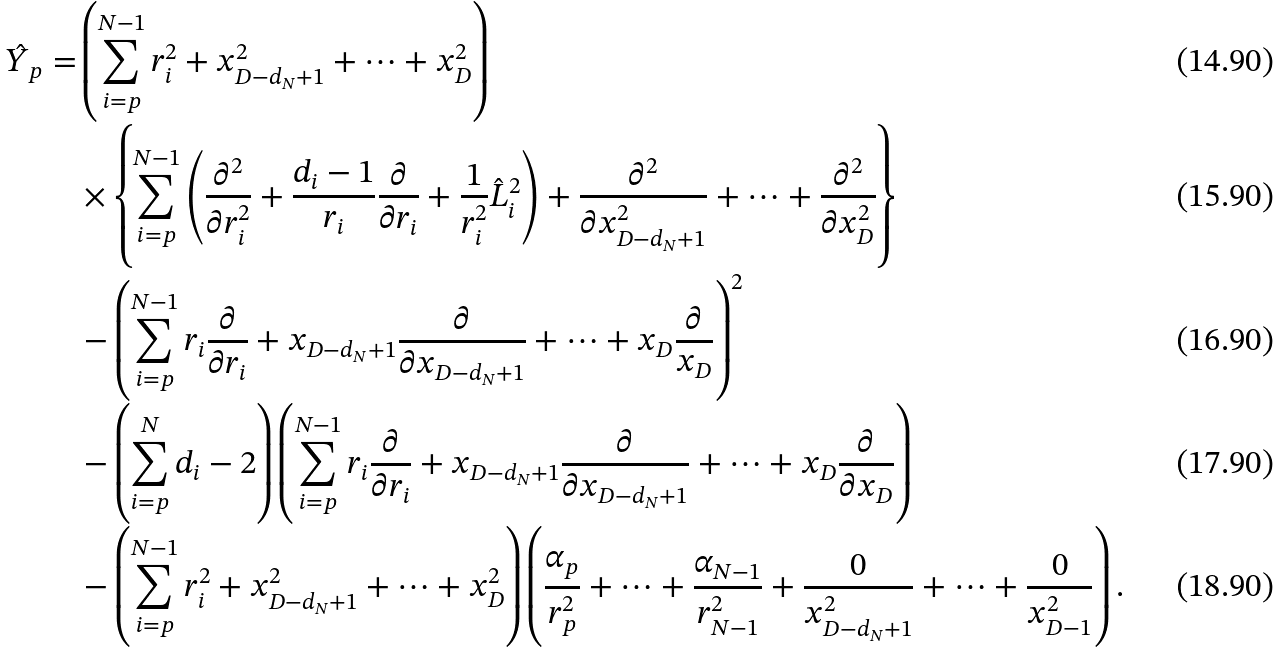<formula> <loc_0><loc_0><loc_500><loc_500>\hat { Y } _ { p } = & \left ( \sum _ { i = p } ^ { N - 1 } r _ { i } ^ { 2 } + x _ { D - d _ { N } + 1 } ^ { 2 } + \cdots + x _ { D } ^ { 2 } \right ) \\ & \times \left \{ \sum _ { i = p } ^ { N - 1 } \left ( \frac { \partial ^ { 2 } } { \partial r _ { i } ^ { 2 } } + \frac { d _ { i } - 1 } { r _ { i } } \frac { \partial } { \partial r _ { i } } + \frac { 1 } { r _ { i } ^ { 2 } } \hat { L } _ { i } ^ { 2 } \right ) + \frac { \partial ^ { 2 } } { \partial x _ { D - d _ { N } + 1 } ^ { 2 } } + \cdots + \frac { \partial ^ { 2 } } { \partial x _ { D } ^ { 2 } } \right \} \\ & - \left ( \sum _ { i = p } ^ { N - 1 } r _ { i } \frac { \partial } { \partial r _ { i } } + x _ { D - d _ { N } + 1 } \frac { \partial } { \partial x _ { D - d _ { N } + 1 } } + \cdots + x _ { D } \frac { \partial } { x _ { D } } \right ) ^ { 2 } \\ & - \left ( \sum _ { i = p } ^ { N } d _ { i } - 2 \right ) \left ( \sum _ { i = p } ^ { N - 1 } r _ { i } \frac { \partial } { \partial r _ { i } } + x _ { D - d _ { N } + 1 } \frac { \partial } { \partial x _ { D - d _ { N } + 1 } } + \cdots + x _ { D } \frac { \partial } { \partial x _ { D } } \right ) \\ & - \left ( \sum _ { i = p } ^ { N - 1 } r _ { i } ^ { 2 } + x _ { D - d _ { N } + 1 } ^ { 2 } + \cdots + x _ { D } ^ { 2 } \right ) \left ( \frac { \alpha _ { p } } { r _ { p } ^ { 2 } } + \cdots + \frac { \alpha _ { N - 1 } } { r _ { N - 1 } ^ { 2 } } + \frac { 0 } { x _ { D - d _ { N } + 1 } ^ { 2 } } + \cdots + \frac { 0 } { x _ { D - 1 } ^ { 2 } } \right ) .</formula> 